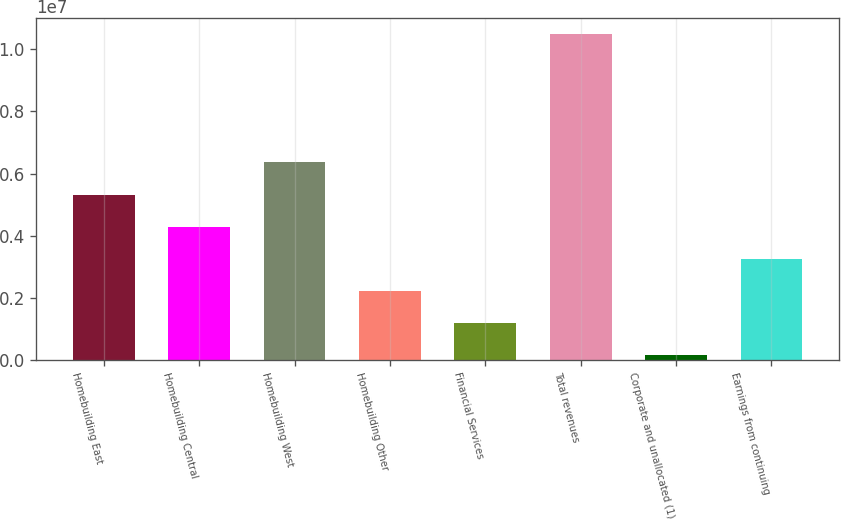Convert chart. <chart><loc_0><loc_0><loc_500><loc_500><bar_chart><fcel>Homebuilding East<fcel>Homebuilding Central<fcel>Homebuilding West<fcel>Homebuilding Other<fcel>Financial Services<fcel>Total revenues<fcel>Corporate and unallocated (1)<fcel>Earnings from continuing<nl><fcel>5.32134e+06<fcel>4.28542e+06<fcel>6.35727e+06<fcel>2.21357e+06<fcel>1.17765e+06<fcel>1.0501e+07<fcel>141722<fcel>3.2495e+06<nl></chart> 